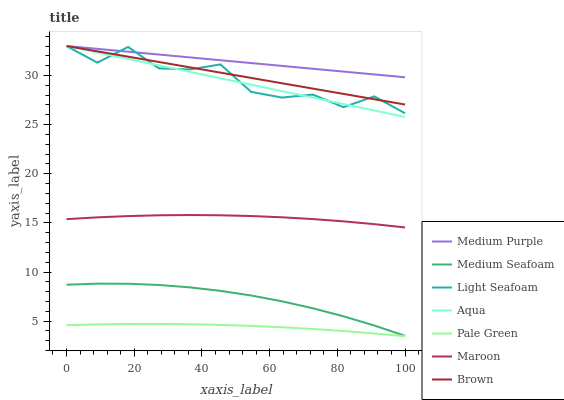Does Pale Green have the minimum area under the curve?
Answer yes or no. Yes. Does Medium Purple have the maximum area under the curve?
Answer yes or no. Yes. Does Aqua have the minimum area under the curve?
Answer yes or no. No. Does Aqua have the maximum area under the curve?
Answer yes or no. No. Is Brown the smoothest?
Answer yes or no. Yes. Is Light Seafoam the roughest?
Answer yes or no. Yes. Is Aqua the smoothest?
Answer yes or no. No. Is Aqua the roughest?
Answer yes or no. No. Does Pale Green have the lowest value?
Answer yes or no. Yes. Does Aqua have the lowest value?
Answer yes or no. No. Does Light Seafoam have the highest value?
Answer yes or no. Yes. Does Maroon have the highest value?
Answer yes or no. No. Is Maroon less than Medium Purple?
Answer yes or no. Yes. Is Brown greater than Medium Seafoam?
Answer yes or no. Yes. Does Brown intersect Light Seafoam?
Answer yes or no. Yes. Is Brown less than Light Seafoam?
Answer yes or no. No. Is Brown greater than Light Seafoam?
Answer yes or no. No. Does Maroon intersect Medium Purple?
Answer yes or no. No. 